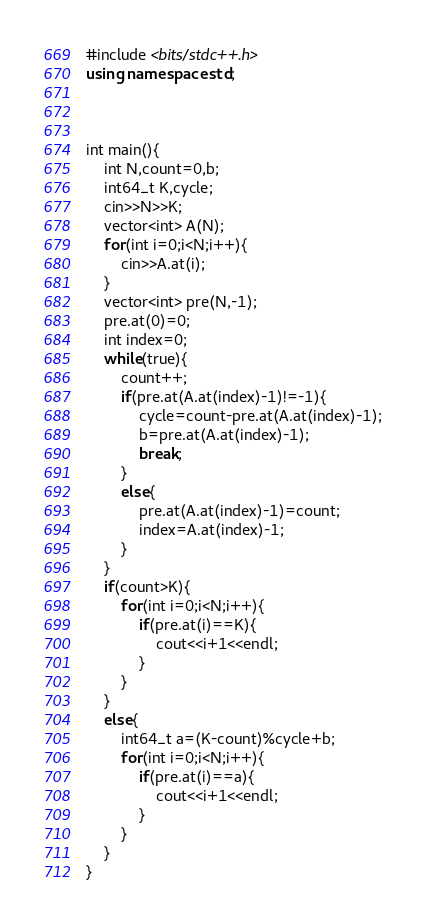<code> <loc_0><loc_0><loc_500><loc_500><_C++_>#include <bits/stdc++.h>
using namespace std;



int main(){
    int N,count=0,b;
    int64_t K,cycle;
    cin>>N>>K;
    vector<int> A(N);
    for(int i=0;i<N;i++){
        cin>>A.at(i);
    }
    vector<int> pre(N,-1);
    pre.at(0)=0;
    int index=0;
    while(true){
        count++;
        if(pre.at(A.at(index)-1)!=-1){
            cycle=count-pre.at(A.at(index)-1);
            b=pre.at(A.at(index)-1);
            break;
        }
        else{
            pre.at(A.at(index)-1)=count;
            index=A.at(index)-1;
        }
    }
    if(count>K){
        for(int i=0;i<N;i++){
            if(pre.at(i)==K){
                cout<<i+1<<endl;
            }
        }
    }
    else{
        int64_t a=(K-count)%cycle+b;
        for(int i=0;i<N;i++){
            if(pre.at(i)==a){
                cout<<i+1<<endl;
            }
        }
    }
}</code> 